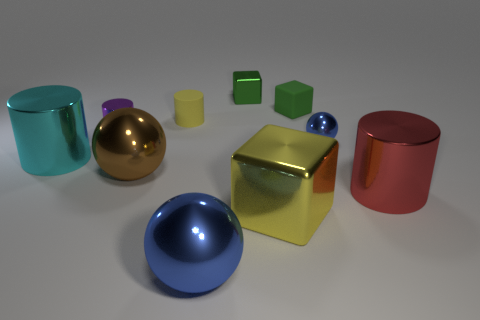Subtract all purple cubes. Subtract all blue balls. How many cubes are left? 3 Subtract all yellow spheres. How many blue cubes are left? 0 Add 3 reds. How many tiny things exist? 0 Subtract all tiny cyan cubes. Subtract all small green metallic cubes. How many objects are left? 9 Add 3 brown things. How many brown things are left? 4 Add 8 small yellow matte cylinders. How many small yellow matte cylinders exist? 9 Subtract all yellow cubes. How many cubes are left? 2 Subtract all cyan metallic cylinders. How many cylinders are left? 3 Subtract 0 cyan cubes. How many objects are left? 10 How many green blocks must be subtracted to get 1 green blocks? 1 